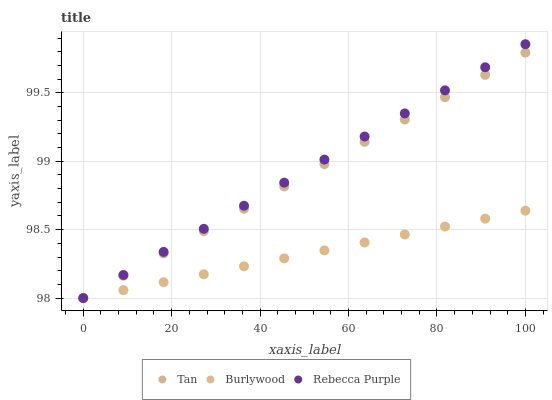Does Burlywood have the minimum area under the curve?
Answer yes or no. Yes. Does Rebecca Purple have the maximum area under the curve?
Answer yes or no. Yes. Does Tan have the minimum area under the curve?
Answer yes or no. No. Does Tan have the maximum area under the curve?
Answer yes or no. No. Is Rebecca Purple the smoothest?
Answer yes or no. Yes. Is Burlywood the roughest?
Answer yes or no. Yes. Is Tan the smoothest?
Answer yes or no. No. Is Tan the roughest?
Answer yes or no. No. Does Burlywood have the lowest value?
Answer yes or no. Yes. Does Rebecca Purple have the highest value?
Answer yes or no. Yes. Does Tan have the highest value?
Answer yes or no. No. Does Burlywood intersect Rebecca Purple?
Answer yes or no. Yes. Is Burlywood less than Rebecca Purple?
Answer yes or no. No. Is Burlywood greater than Rebecca Purple?
Answer yes or no. No. 